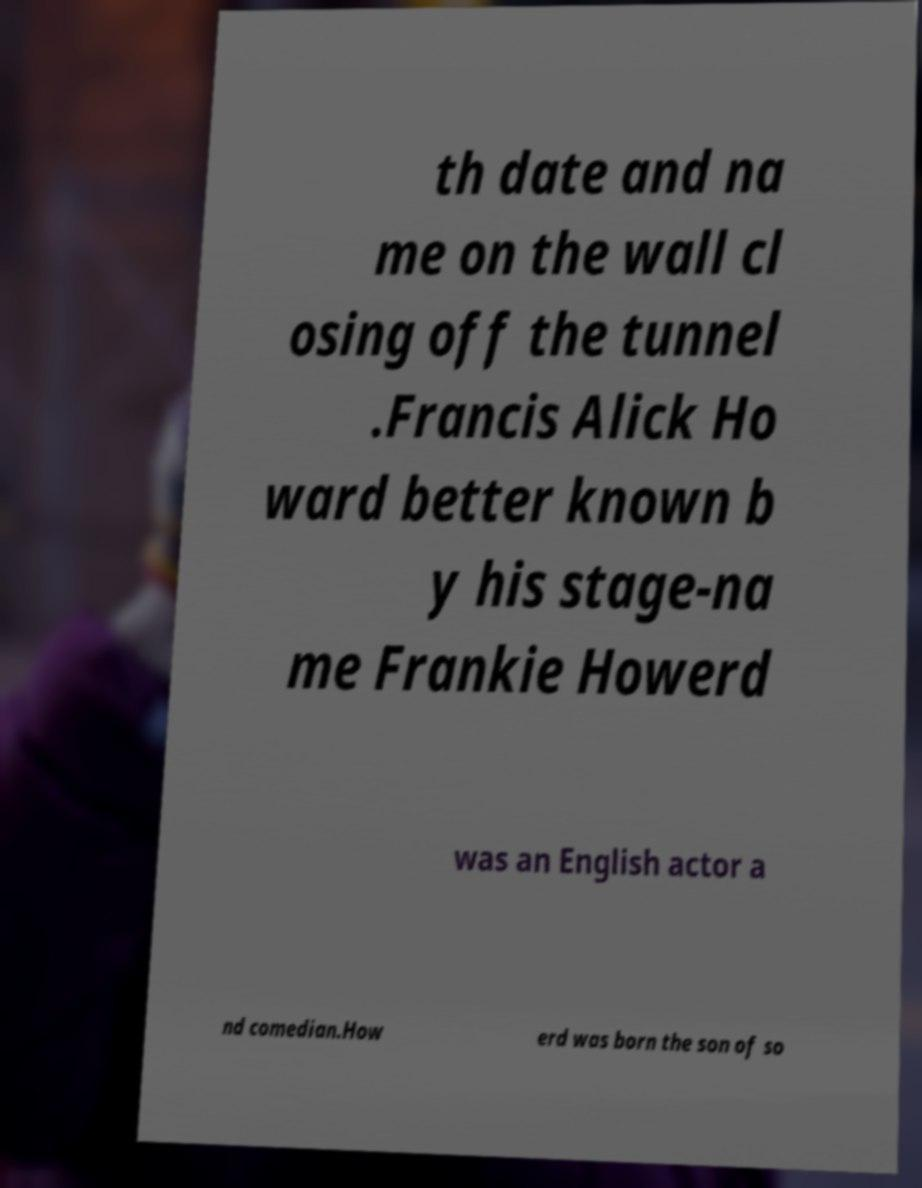Can you read and provide the text displayed in the image?This photo seems to have some interesting text. Can you extract and type it out for me? th date and na me on the wall cl osing off the tunnel .Francis Alick Ho ward better known b y his stage-na me Frankie Howerd was an English actor a nd comedian.How erd was born the son of so 